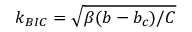Convert formula to latex. <formula><loc_0><loc_0><loc_500><loc_500>k _ { B I C } = \sqrt { \beta ( b - b _ { c } ) / C }</formula> 